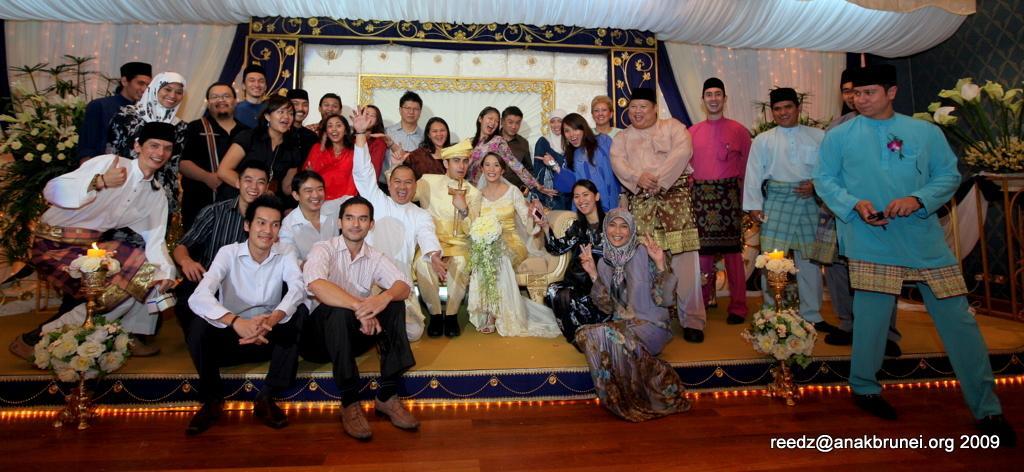In one or two sentences, can you explain what this image depicts? In this image I can see the group of people with different color dresses. To the side of these people I can see the flower vases and bouquets. In the background I can see the curtains which are colorful. I can also see the watermark in the image. 